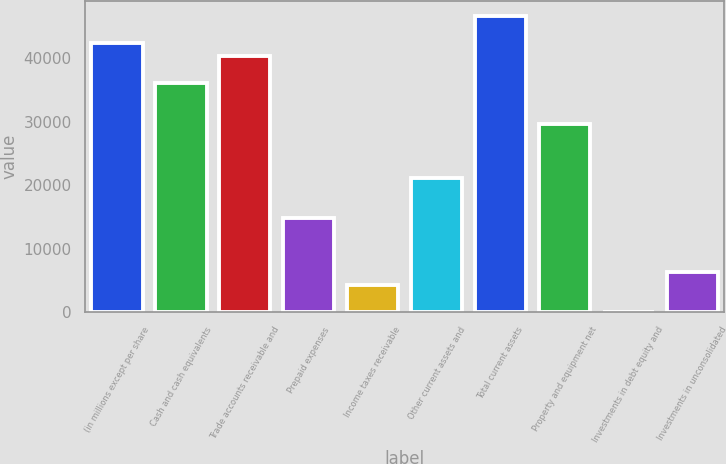<chart> <loc_0><loc_0><loc_500><loc_500><bar_chart><fcel>(in millions except per share<fcel>Cash and cash equivalents<fcel>Trade accounts receivable and<fcel>Prepaid expenses<fcel>Income taxes receivable<fcel>Other current assets and<fcel>Total current assets<fcel>Property and equipment net<fcel>Investments in debt equity and<fcel>Investments in unconsolidated<nl><fcel>42403<fcel>36044.5<fcel>40283.5<fcel>14849.5<fcel>4252<fcel>21208<fcel>46642<fcel>29686<fcel>13<fcel>6371.5<nl></chart> 